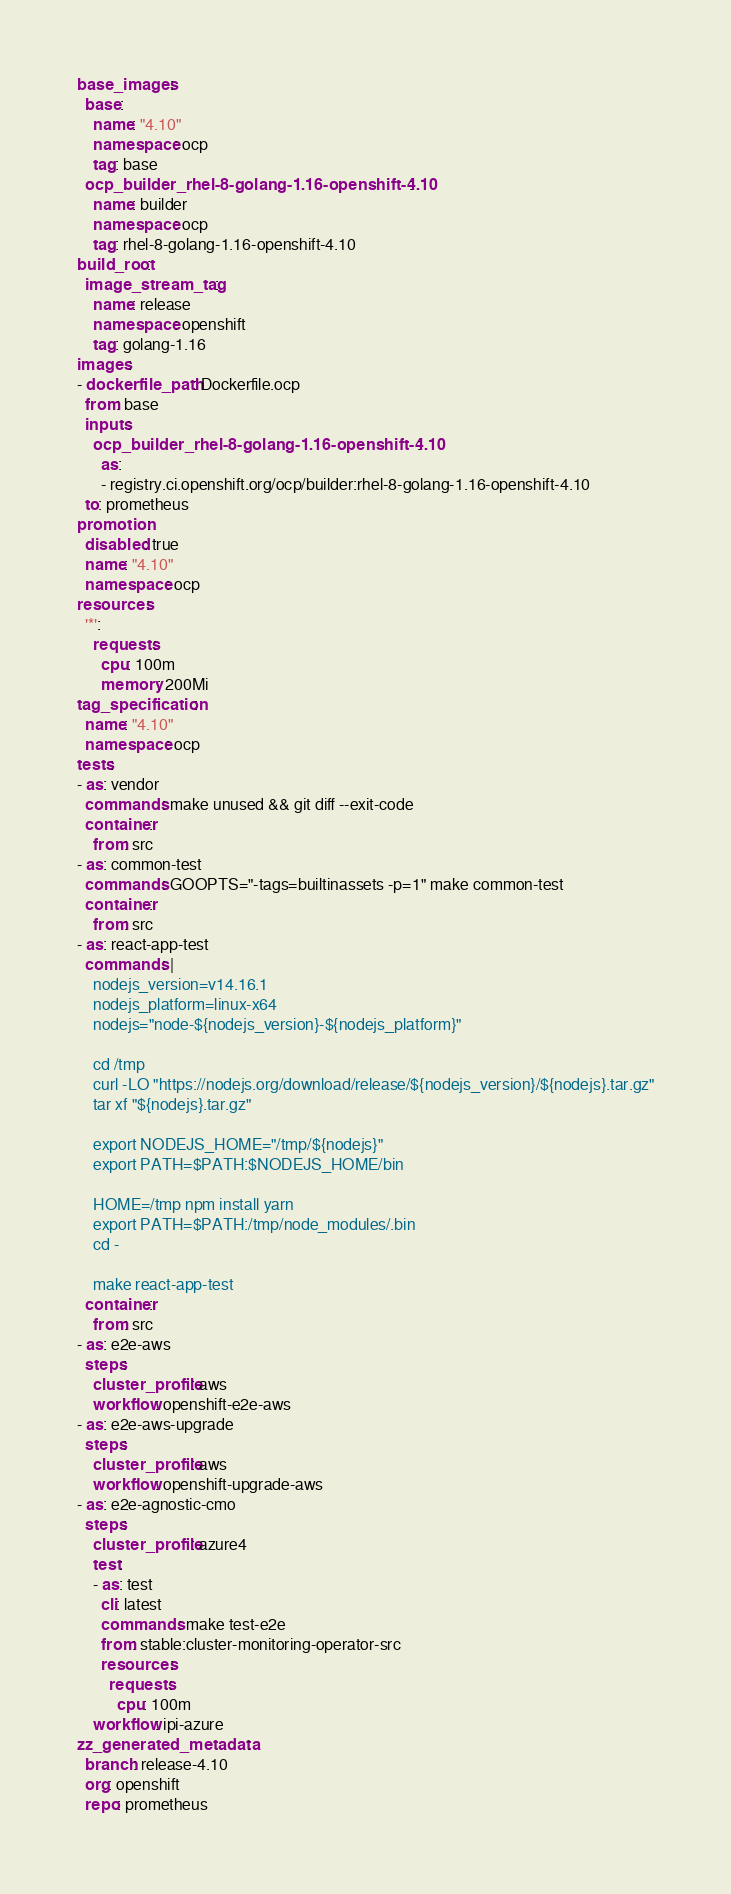<code> <loc_0><loc_0><loc_500><loc_500><_YAML_>base_images:
  base:
    name: "4.10"
    namespace: ocp
    tag: base
  ocp_builder_rhel-8-golang-1.16-openshift-4.10:
    name: builder
    namespace: ocp
    tag: rhel-8-golang-1.16-openshift-4.10
build_root:
  image_stream_tag:
    name: release
    namespace: openshift
    tag: golang-1.16
images:
- dockerfile_path: Dockerfile.ocp
  from: base
  inputs:
    ocp_builder_rhel-8-golang-1.16-openshift-4.10:
      as:
      - registry.ci.openshift.org/ocp/builder:rhel-8-golang-1.16-openshift-4.10
  to: prometheus
promotion:
  disabled: true
  name: "4.10"
  namespace: ocp
resources:
  '*':
    requests:
      cpu: 100m
      memory: 200Mi
tag_specification:
  name: "4.10"
  namespace: ocp
tests:
- as: vendor
  commands: make unused && git diff --exit-code
  container:
    from: src
- as: common-test
  commands: GOOPTS="-tags=builtinassets -p=1" make common-test
  container:
    from: src
- as: react-app-test
  commands: |
    nodejs_version=v14.16.1
    nodejs_platform=linux-x64
    nodejs="node-${nodejs_version}-${nodejs_platform}"

    cd /tmp
    curl -LO "https://nodejs.org/download/release/${nodejs_version}/${nodejs}.tar.gz"
    tar xf "${nodejs}.tar.gz"

    export NODEJS_HOME="/tmp/${nodejs}"
    export PATH=$PATH:$NODEJS_HOME/bin

    HOME=/tmp npm install yarn
    export PATH=$PATH:/tmp/node_modules/.bin
    cd -

    make react-app-test
  container:
    from: src
- as: e2e-aws
  steps:
    cluster_profile: aws
    workflow: openshift-e2e-aws
- as: e2e-aws-upgrade
  steps:
    cluster_profile: aws
    workflow: openshift-upgrade-aws
- as: e2e-agnostic-cmo
  steps:
    cluster_profile: azure4
    test:
    - as: test
      cli: latest
      commands: make test-e2e
      from: stable:cluster-monitoring-operator-src
      resources:
        requests:
          cpu: 100m
    workflow: ipi-azure
zz_generated_metadata:
  branch: release-4.10
  org: openshift
  repo: prometheus
</code> 